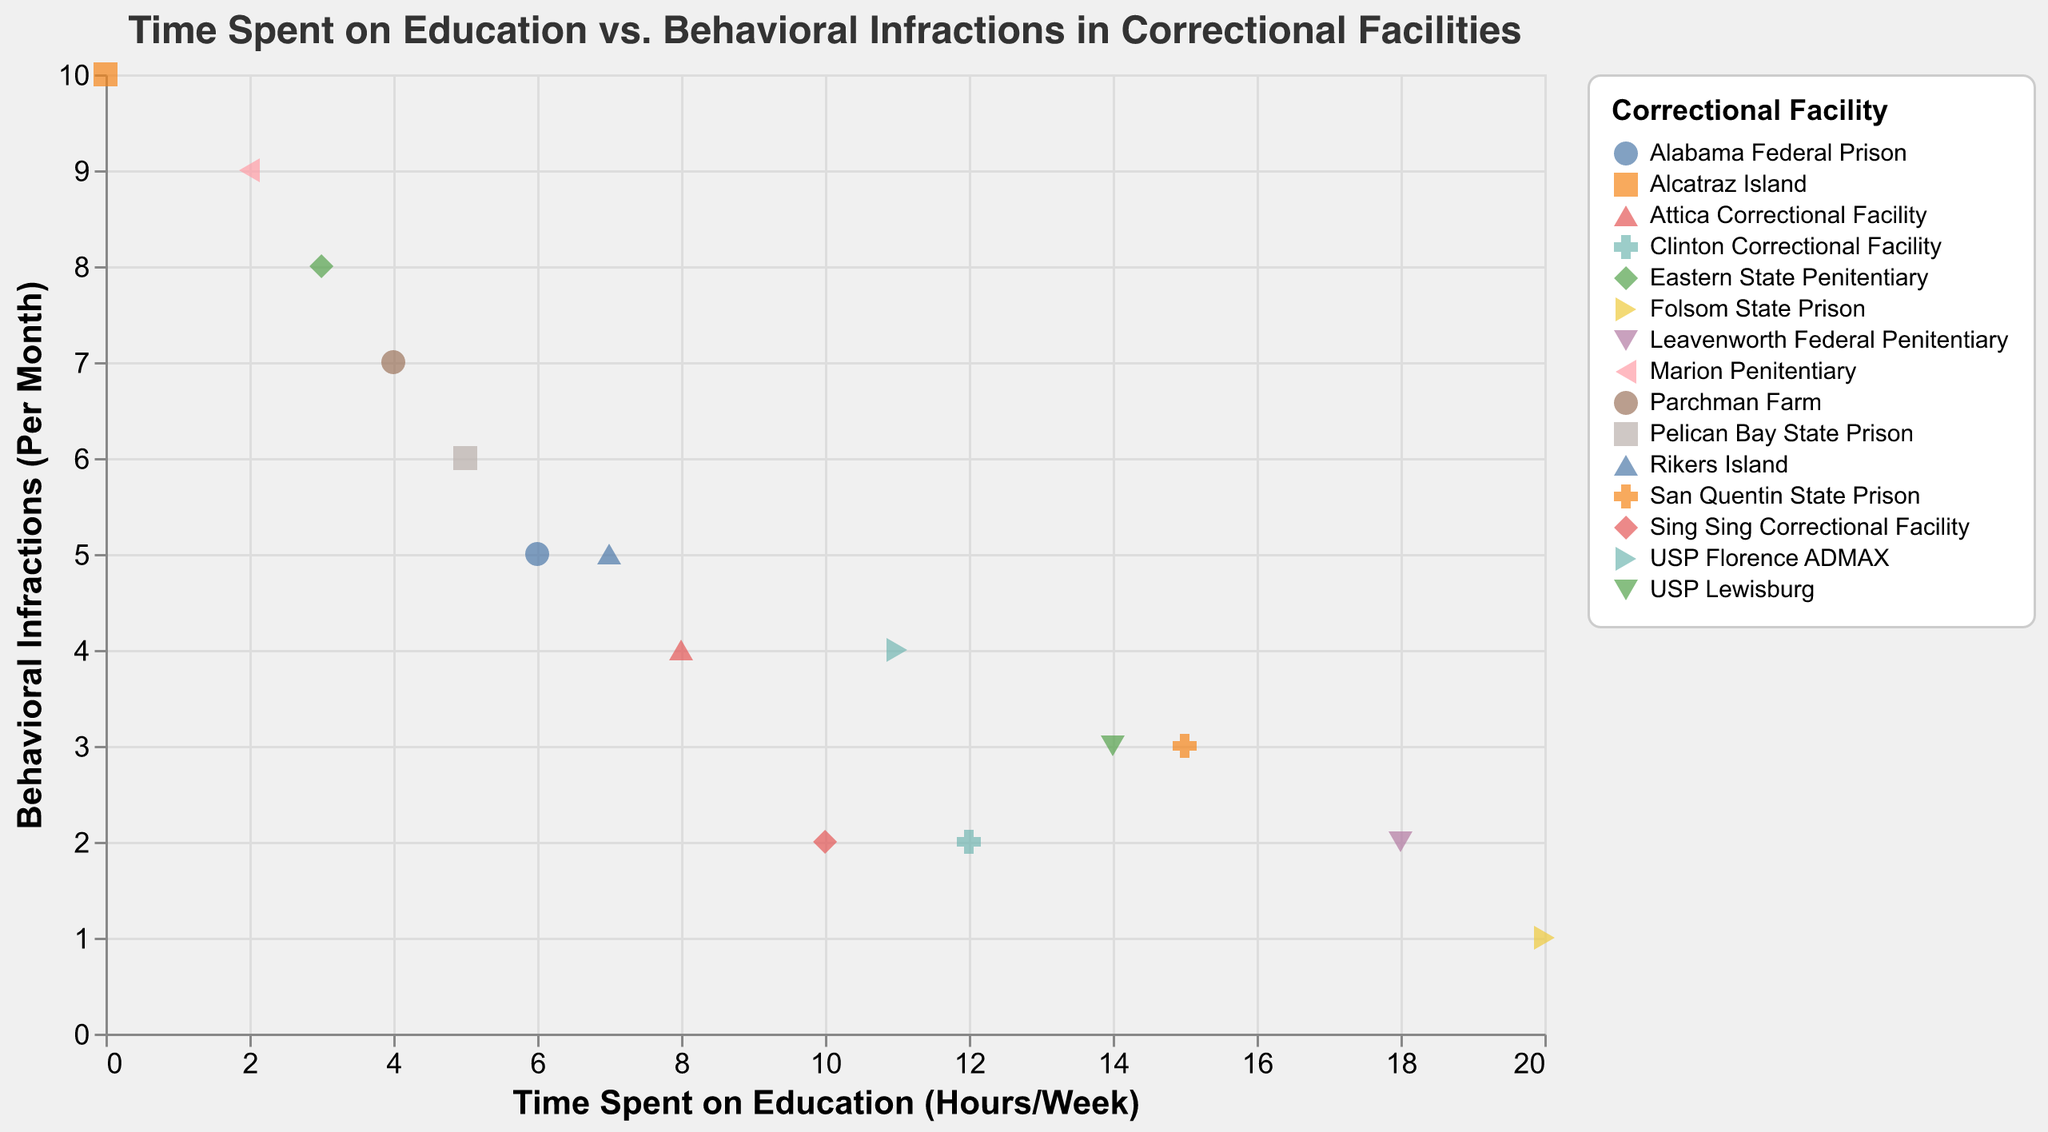What is the title of the plot? The title is displayed at the top of the plot and it reads "Time Spent on Education vs. Behavioral Infractions in Correctional Facilities".
Answer: Time Spent on Education vs. Behavioral Infractions in Correctional Facilities How many data points are plotted for "Folsom State Prison"? Look for points colored uniquely for "Folsom State Prison" in the legend, then count the corresponding points on the plot.
Answer: 1 Which facility has the least amount of time spent on education? Find the point with the minimum value on the x-axis and refer to its corresponding facility.
Answer: Alcatraz Island What is the relationship between time spent on education and behavioral infractions in general? Observe the general trend of points; as the x-axis (time spent on education) increases, note if the y-axis (behavioral infractions) tends to increase or decrease.
Answer: Inverse relationship (more education, fewer infractions) Which facility has the highest number of behavioral infractions? Identify the point with the highest value on the y-axis and refer to its corresponding facility.
Answer: Alcatraz Island What are the behavioral infractions for the facilities where inmates spend 10 or more hours per week on education? Look for points where x-values are 10 or more, then note the y-values (behavioral infractions) and their corresponding facilities.
Answer: Sing Sing Correctional Facility (2), San Quentin State Prison (3), Clinton Correctional Facility (2), Leavenworth Federal Penitentiary (2), USP Lewisburg (3), USP Florence ADMAX (4) Which facility has the lowest number of behavioral infractions and how much time do inmates spend on education there? Identify the point with the lowest value on the y-axis and refer to its corresponding facility and x-value.
Answer: Folsom State Prison, 20 hours/week Compare the number of behavioral infractions between inmates at "San Quentin State Prison" and "Rikers Island". Locate the points for both facilities using the color legend, note their y-values, and compare them.
Answer: San Quentin State Prison has 3 infractions, Rikers Island has 5 infractions What is the average amount of time spent on education by inmates at "Sing Sing Correctional Facility" and "Clinton Correctional Facility"? Add the education hours of both facilities and divide by 2.
Answer: (10 + 12) / 2 = 11 hours/week How many facilities have inmates that spend fewer than 5 hours per week on education? Count the number of points with x-values less than 5.
Answer: 3 